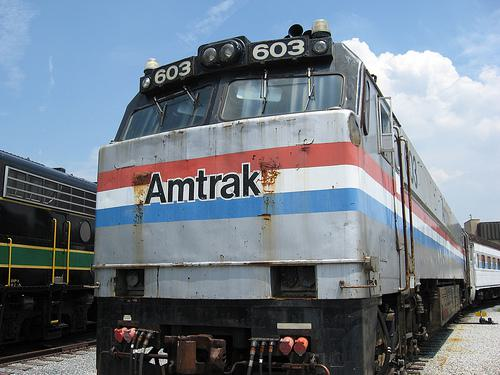What does the condition of this locomotive suggest? The image shows some wear and rust, indicating that the locomotive has been in service for some time and has been exposed to the elements, suggesting a rich operational history. Is Amtrak still using these models? It's difficult to say without a specific model number and the year the image was taken, but typically such models may eventually be retired or replaced with newer, more efficient ones over time. 